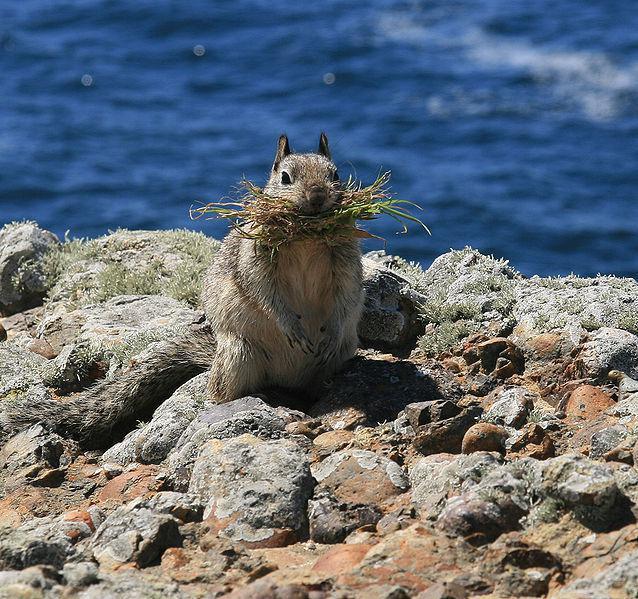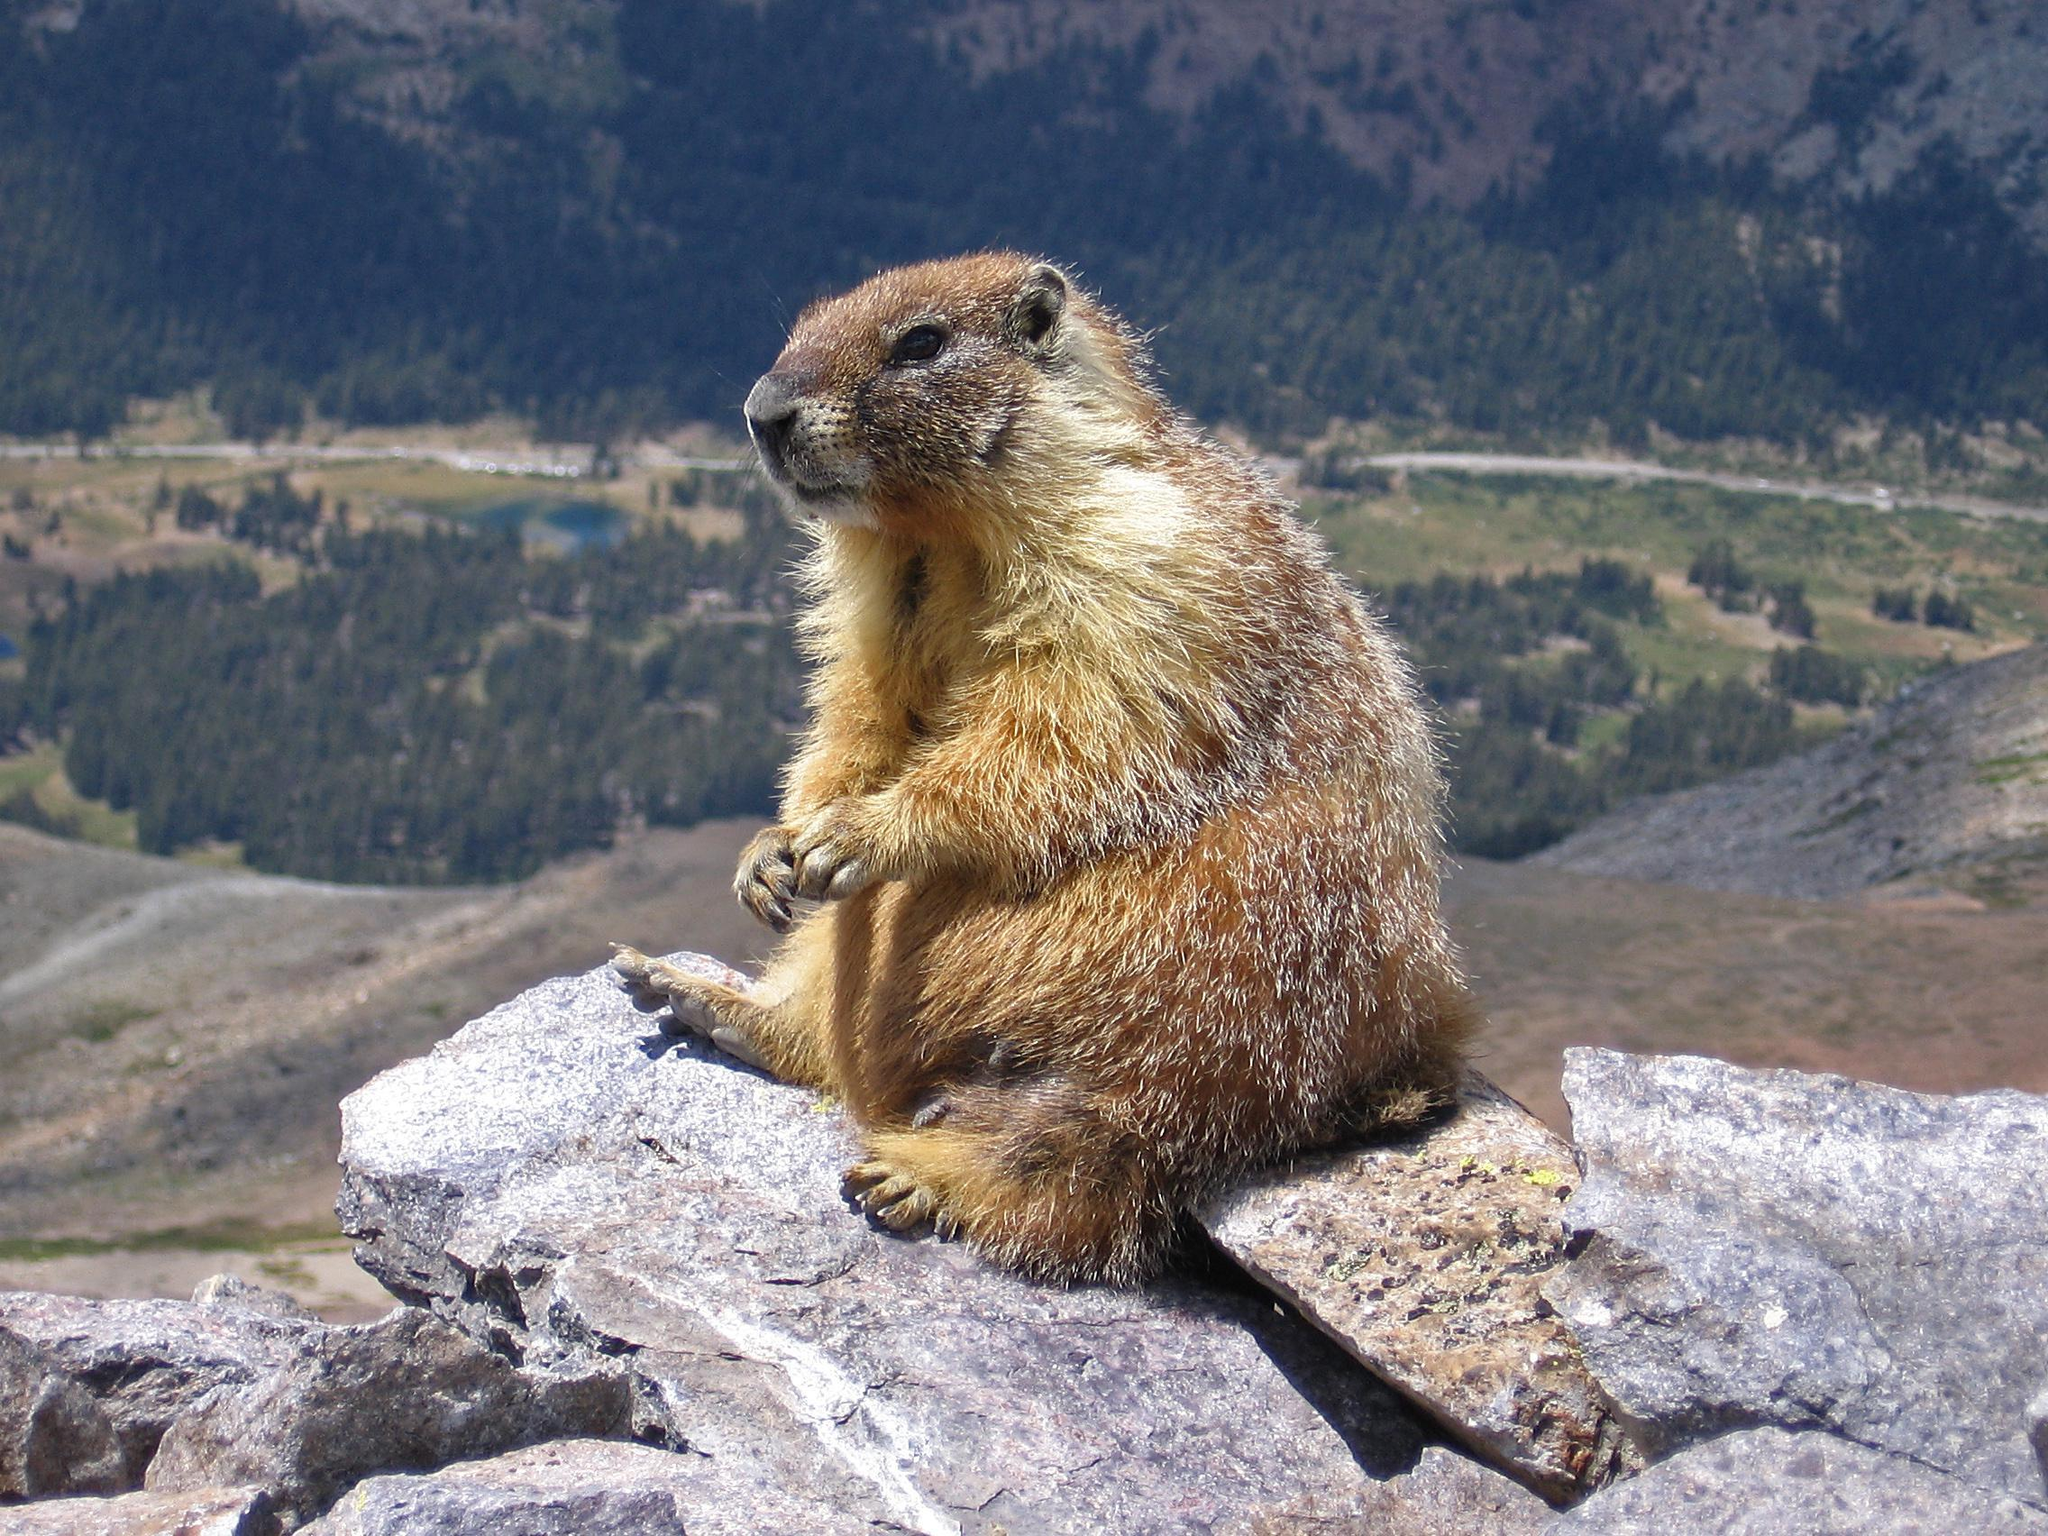The first image is the image on the left, the second image is the image on the right. Analyze the images presented: Is the assertion "The animal in the image on the left is facing left." valid? Answer yes or no. No. 